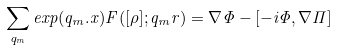Convert formula to latex. <formula><loc_0><loc_0><loc_500><loc_500>\sum _ { { q } _ { m } } e x p ( { q } _ { m } . { x } ) { F } ( [ \rho ] ; { q } _ { m } r ) = \nabla \Phi - [ - i \Phi , \nabla \Pi ]</formula> 